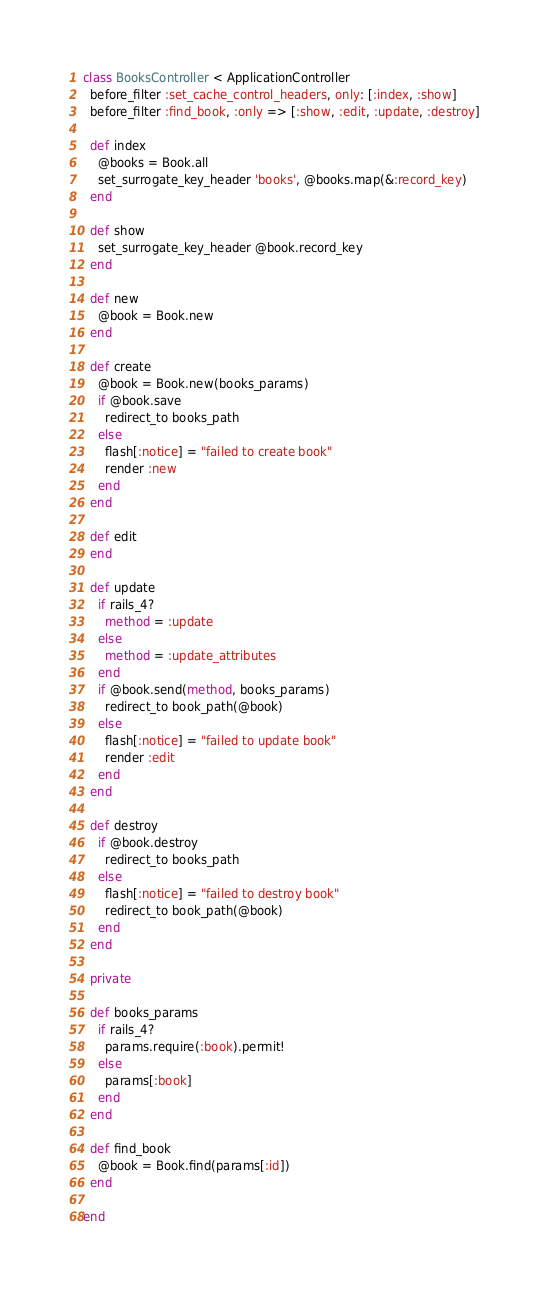<code> <loc_0><loc_0><loc_500><loc_500><_Ruby_>class BooksController < ApplicationController
  before_filter :set_cache_control_headers, only: [:index, :show]
  before_filter :find_book, :only => [:show, :edit, :update, :destroy]

  def index
    @books = Book.all
    set_surrogate_key_header 'books', @books.map(&:record_key)
  end

  def show
    set_surrogate_key_header @book.record_key
  end

  def new
    @book = Book.new
  end

  def create
    @book = Book.new(books_params)
    if @book.save
      redirect_to books_path
    else
      flash[:notice] = "failed to create book"
      render :new
    end
  end

  def edit
  end

  def update
    if rails_4?
      method = :update
    else
      method = :update_attributes
    end
    if @book.send(method, books_params)
      redirect_to book_path(@book)
    else
      flash[:notice] = "failed to update book"
      render :edit
    end
  end

  def destroy
    if @book.destroy
      redirect_to books_path
    else
      flash[:notice] = "failed to destroy book"
      redirect_to book_path(@book)
    end
  end

  private

  def books_params
    if rails_4?
      params.require(:book).permit!
    else
      params[:book]
    end
  end

  def find_book
    @book = Book.find(params[:id])
  end

end
</code> 